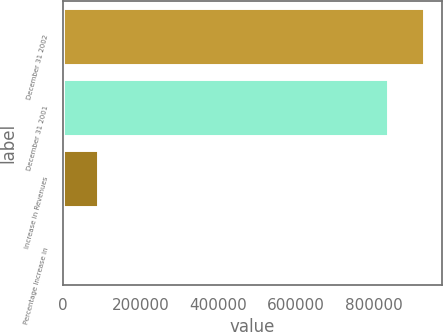Convert chart to OTSL. <chart><loc_0><loc_0><loc_500><loc_500><bar_chart><fcel>December 31 2002<fcel>December 31 2001<fcel>Increase in Revenues<fcel>Percentage Increase in<nl><fcel>928812<fcel>837994<fcel>90826.5<fcel>8.4<nl></chart> 